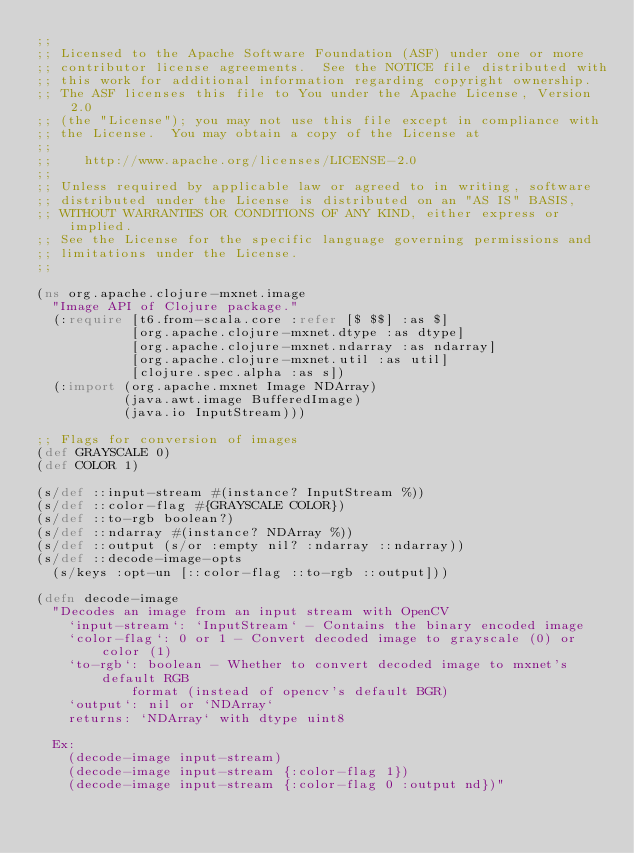Convert code to text. <code><loc_0><loc_0><loc_500><loc_500><_Clojure_>;;
;; Licensed to the Apache Software Foundation (ASF) under one or more
;; contributor license agreements.  See the NOTICE file distributed with
;; this work for additional information regarding copyright ownership.
;; The ASF licenses this file to You under the Apache License, Version 2.0
;; (the "License"); you may not use this file except in compliance with
;; the License.  You may obtain a copy of the License at
;;
;;    http://www.apache.org/licenses/LICENSE-2.0
;;
;; Unless required by applicable law or agreed to in writing, software
;; distributed under the License is distributed on an "AS IS" BASIS,
;; WITHOUT WARRANTIES OR CONDITIONS OF ANY KIND, either express or implied.
;; See the License for the specific language governing permissions and
;; limitations under the License.
;;

(ns org.apache.clojure-mxnet.image
  "Image API of Clojure package."
  (:require [t6.from-scala.core :refer [$ $$] :as $]
            [org.apache.clojure-mxnet.dtype :as dtype]
            [org.apache.clojure-mxnet.ndarray :as ndarray]
            [org.apache.clojure-mxnet.util :as util]
            [clojure.spec.alpha :as s])
  (:import (org.apache.mxnet Image NDArray)
           (java.awt.image BufferedImage)
           (java.io InputStream)))

;; Flags for conversion of images
(def GRAYSCALE 0)
(def COLOR 1)

(s/def ::input-stream #(instance? InputStream %))
(s/def ::color-flag #{GRAYSCALE COLOR})
(s/def ::to-rgb boolean?)
(s/def ::ndarray #(instance? NDArray %))
(s/def ::output (s/or :empty nil? :ndarray ::ndarray))
(s/def ::decode-image-opts
  (s/keys :opt-un [::color-flag ::to-rgb ::output]))

(defn decode-image
  "Decodes an image from an input stream with OpenCV
    `input-stream`: `InputStream` - Contains the binary encoded image
    `color-flag`: 0 or 1 - Convert decoded image to grayscale (0) or color (1)
    `to-rgb`: boolean - Whether to convert decoded image to mxnet's default RGB
            format (instead of opencv's default BGR)
    `output`: nil or `NDArray`
    returns: `NDArray` with dtype uint8

  Ex:
    (decode-image input-stream)
    (decode-image input-stream {:color-flag 1})
    (decode-image input-stream {:color-flag 0 :output nd})"</code> 